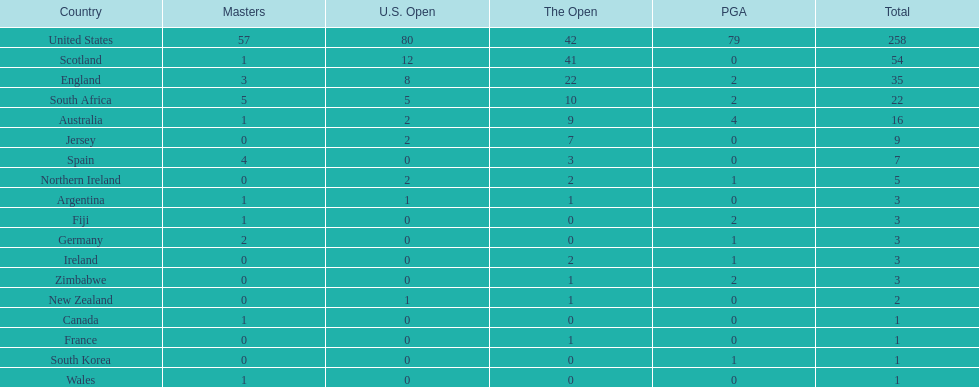How many u.s. open successes does fiji have? 0. 